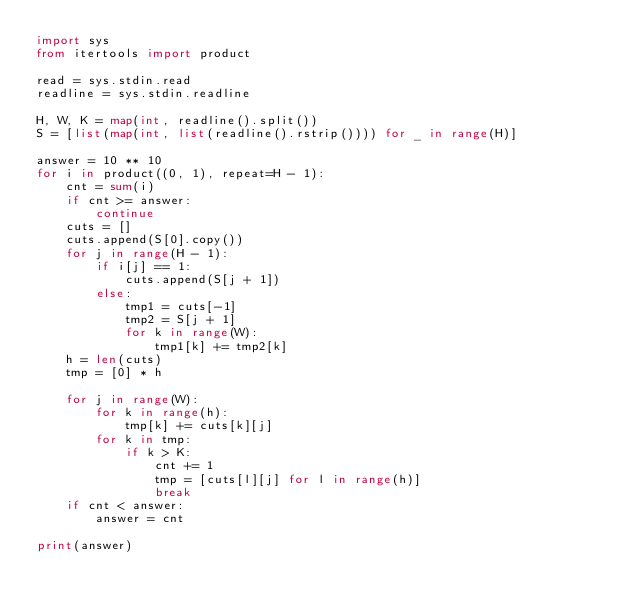Convert code to text. <code><loc_0><loc_0><loc_500><loc_500><_Python_>import sys
from itertools import product

read = sys.stdin.read
readline = sys.stdin.readline

H, W, K = map(int, readline().split())
S = [list(map(int, list(readline().rstrip()))) for _ in range(H)]

answer = 10 ** 10
for i in product((0, 1), repeat=H - 1):
    cnt = sum(i)
    if cnt >= answer:
        continue
    cuts = []
    cuts.append(S[0].copy())
    for j in range(H - 1):
        if i[j] == 1:
            cuts.append(S[j + 1])
        else:
            tmp1 = cuts[-1]
            tmp2 = S[j + 1]
            for k in range(W):
                tmp1[k] += tmp2[k]
    h = len(cuts)
    tmp = [0] * h

    for j in range(W):
        for k in range(h):
            tmp[k] += cuts[k][j]
        for k in tmp:
            if k > K:
                cnt += 1
                tmp = [cuts[l][j] for l in range(h)]
                break
    if cnt < answer:
        answer = cnt

print(answer)
</code> 